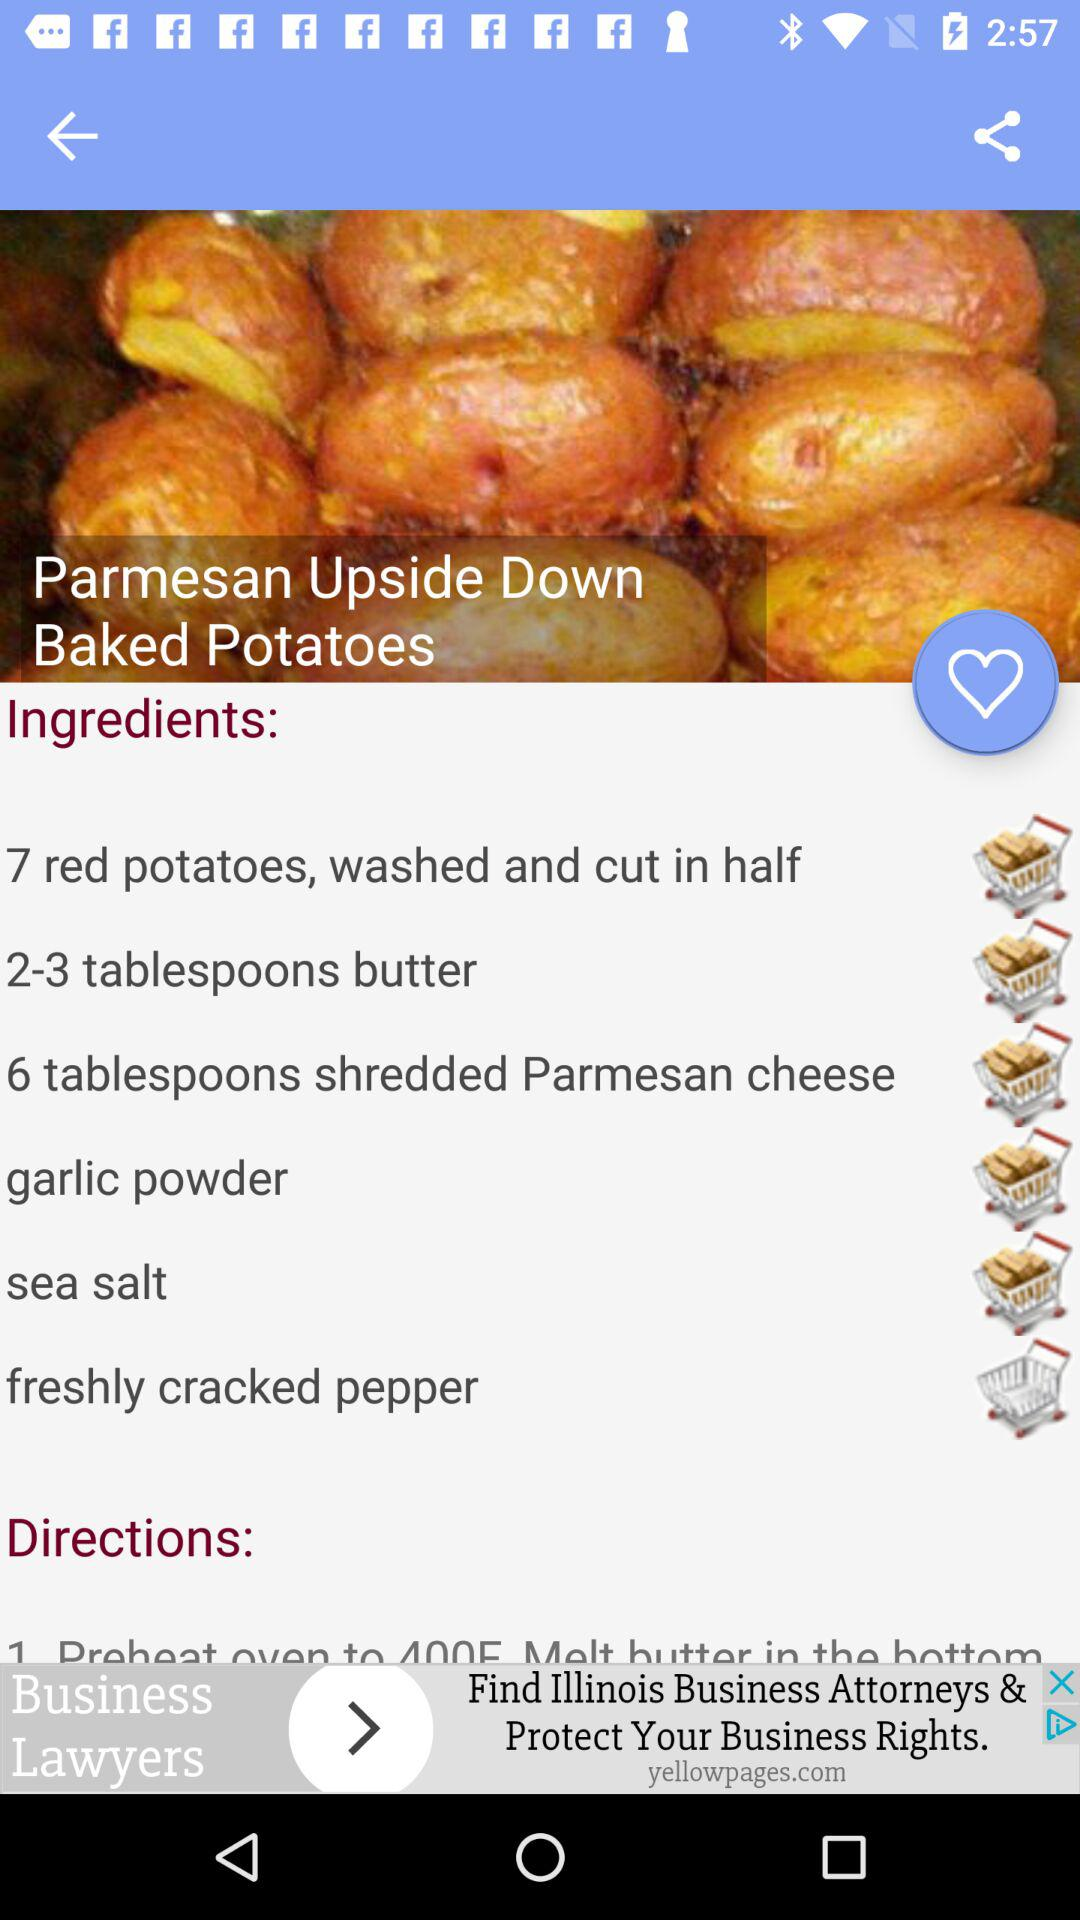What's the number of red potatoes, washed and cut in half? The number is 7. 